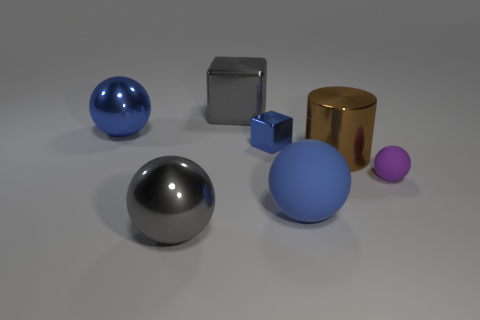Add 1 small matte balls. How many objects exist? 8 Subtract all cylinders. How many objects are left? 6 Add 2 big spheres. How many big spheres exist? 5 Subtract 0 purple cubes. How many objects are left? 7 Subtract all large metallic blocks. Subtract all blue metallic things. How many objects are left? 4 Add 4 blue balls. How many blue balls are left? 6 